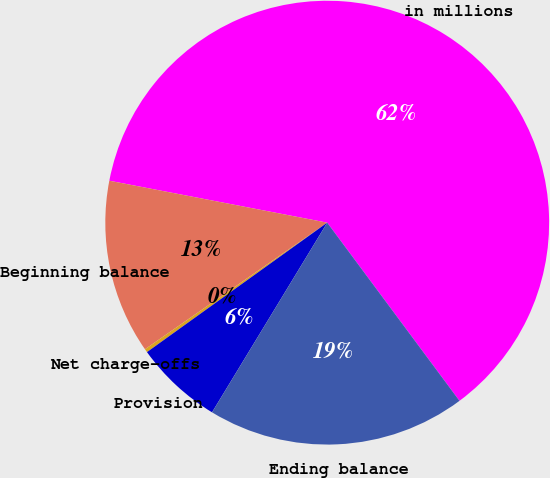Convert chart to OTSL. <chart><loc_0><loc_0><loc_500><loc_500><pie_chart><fcel>in millions<fcel>Beginning balance<fcel>Net charge-offs<fcel>Provision<fcel>Ending balance<nl><fcel>61.81%<fcel>12.69%<fcel>0.25%<fcel>6.4%<fcel>18.85%<nl></chart> 